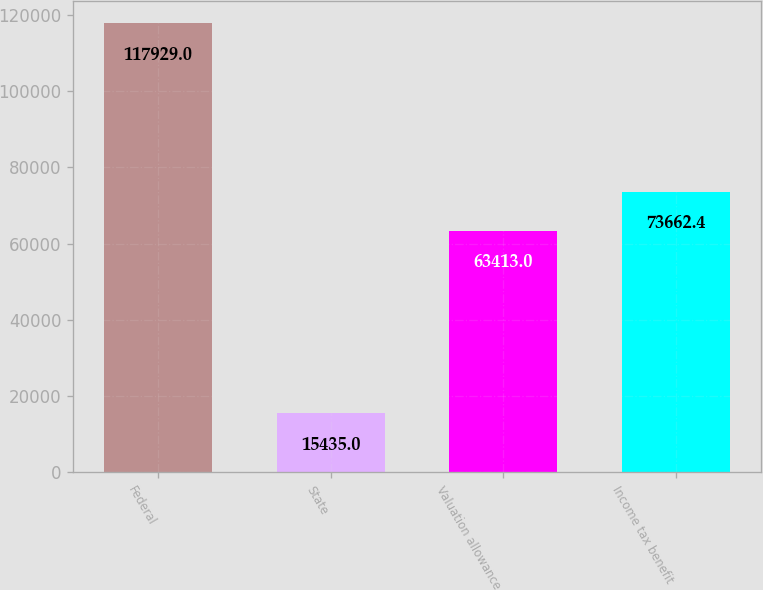Convert chart. <chart><loc_0><loc_0><loc_500><loc_500><bar_chart><fcel>Federal<fcel>State<fcel>Valuation allowance<fcel>Income tax benefit<nl><fcel>117929<fcel>15435<fcel>63413<fcel>73662.4<nl></chart> 